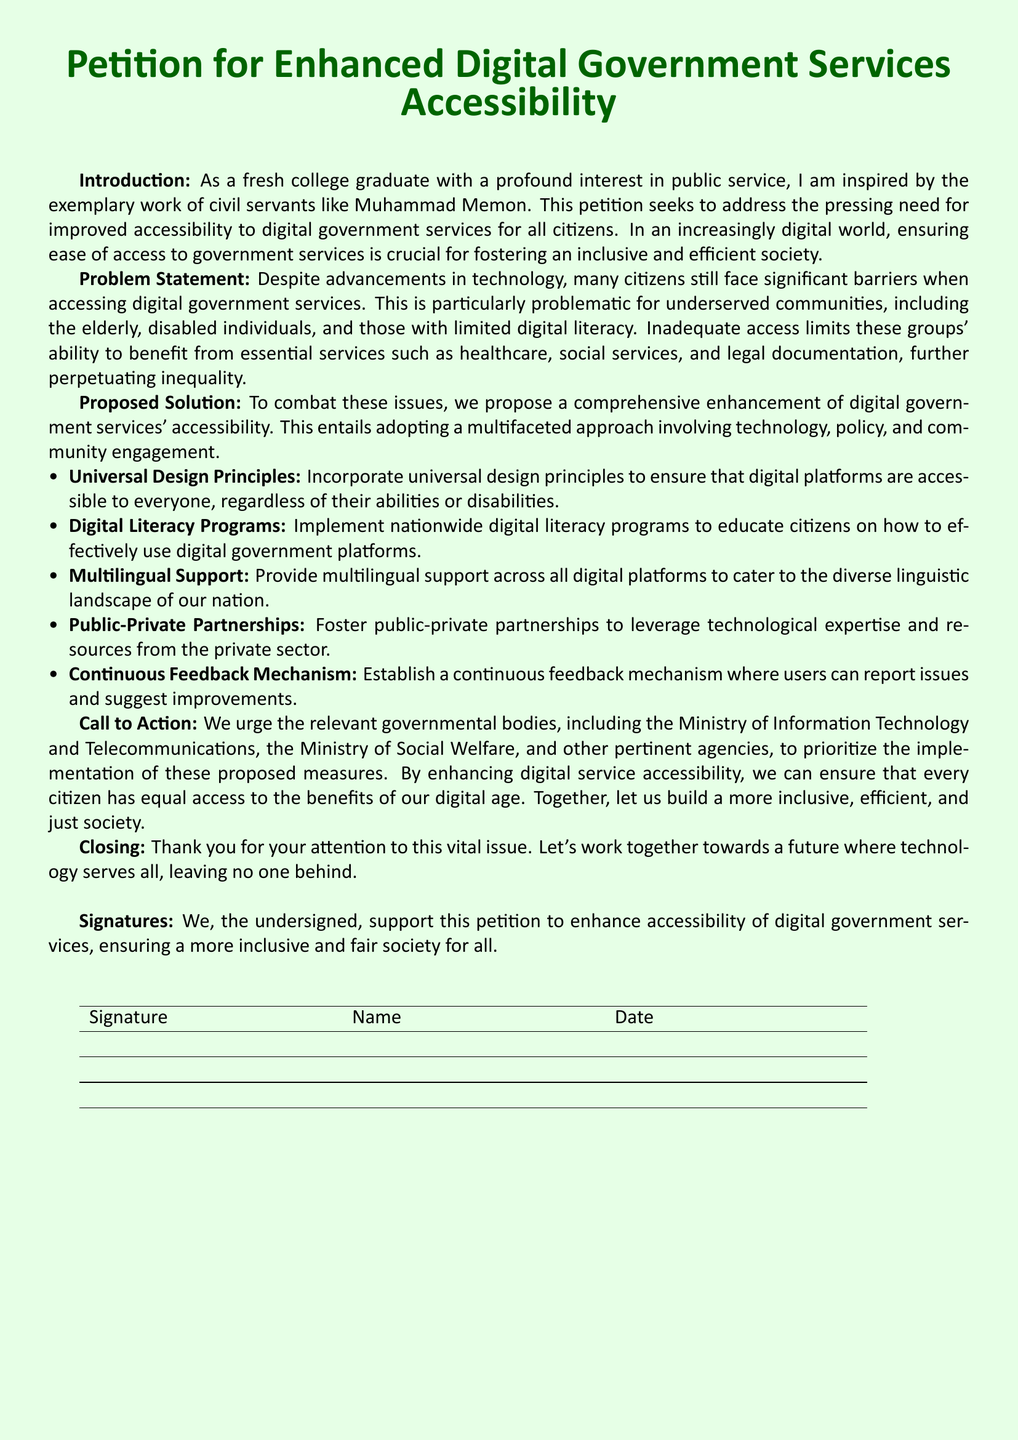What is the title of the petition? The title of the petition is prominently presented at the beginning of the document.
Answer: Petition for Enhanced Digital Government Services Accessibility Who is the petition addressed to? The petition calls on relevant governmental bodies, indicating a wide range of stakeholders involved.
Answer: Ministry of Information Technology and Telecommunications, Ministry of Social Welfare What are the five proposed solutions? The document lists five specific strategies aimed at enhancing accessibility in digital services.
Answer: Universal Design Principles, Digital Literacy Programs, Multilingual Support, Public-Private Partnerships, Continuous Feedback Mechanism What color is used for the text and page background? The document uses a specific color scheme for aesthetic appeal and readability.
Answer: Dark green text and light green background What is the purpose of the continuous feedback mechanism? The feedback mechanism allows users to report problems and suggest enhancements.
Answer: Report issues and suggest improvements How many signatures are required for the petition? The document includes a section for signatures, but it does not specify a number.
Answer: Not specified What is the main issue the petition aims to address? The introduction highlights the critical issue that many face regarding government digital services.
Answer: Accessibility barriers When was the petition drafted? The document does not provide a specific date, but it includes a space for dates alongside signatures.
Answer: Not specified 